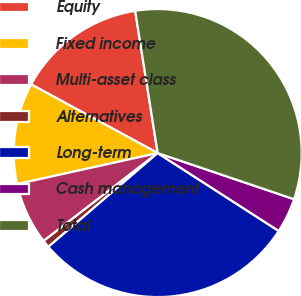Convert chart. <chart><loc_0><loc_0><loc_500><loc_500><pie_chart><fcel>Equity<fcel>Fixed income<fcel>Multi-asset class<fcel>Alternatives<fcel>Long-term<fcel>Cash management<fcel>Total<nl><fcel>14.59%<fcel>11.37%<fcel>6.99%<fcel>0.84%<fcel>29.61%<fcel>3.91%<fcel>32.69%<nl></chart> 